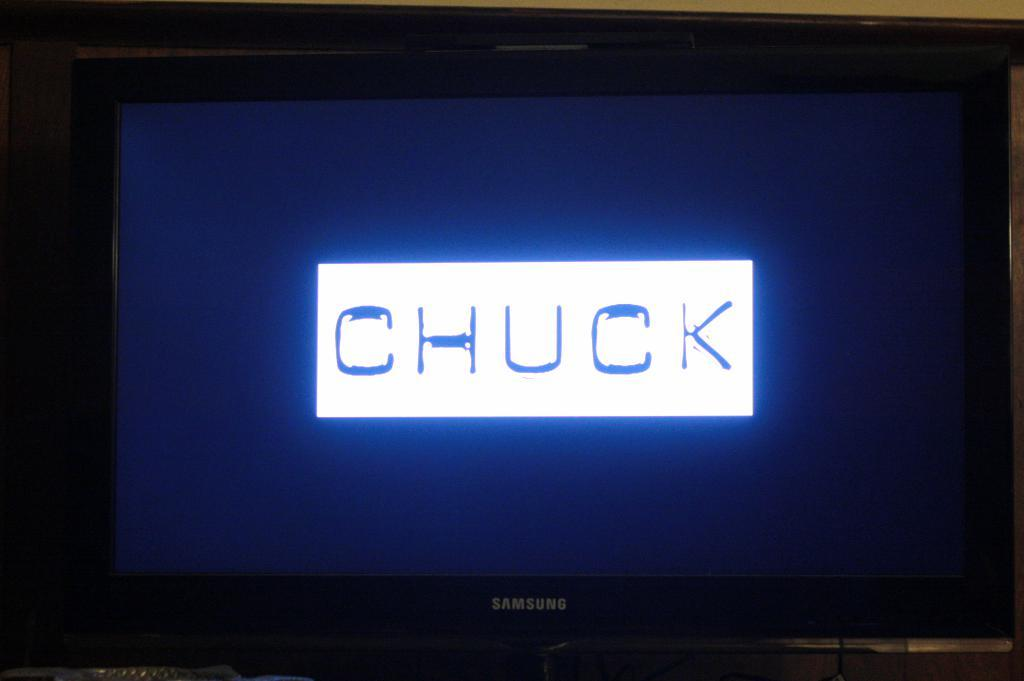<image>
Offer a succinct explanation of the picture presented. A Samsung TV displaying a graphic that says CHUCK. 